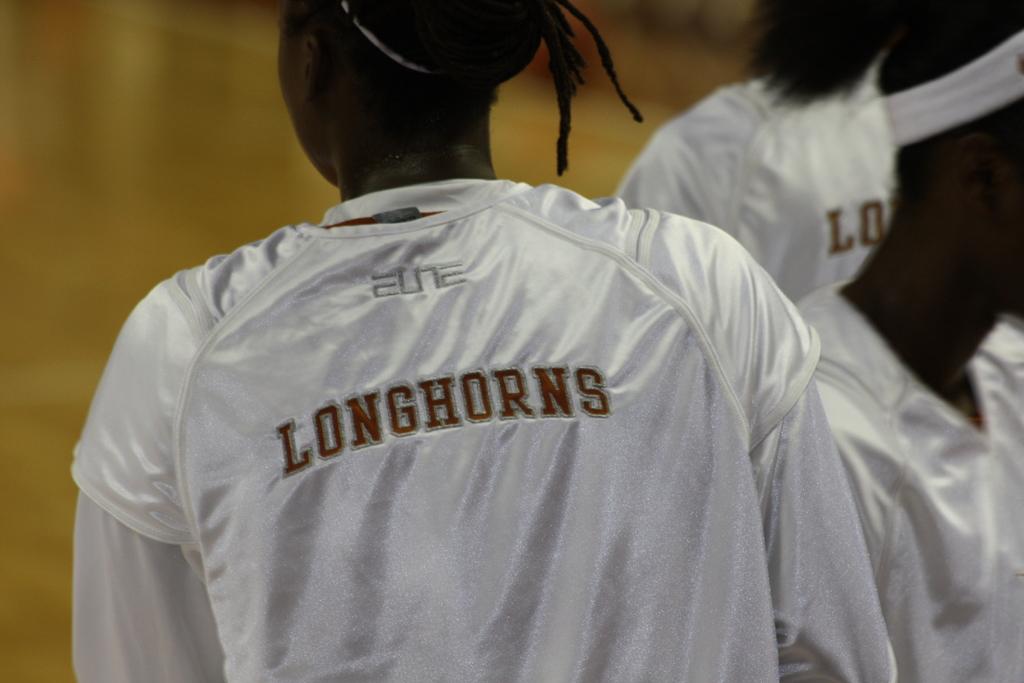What is the brand of the shirt?
Provide a succinct answer. Elite. 